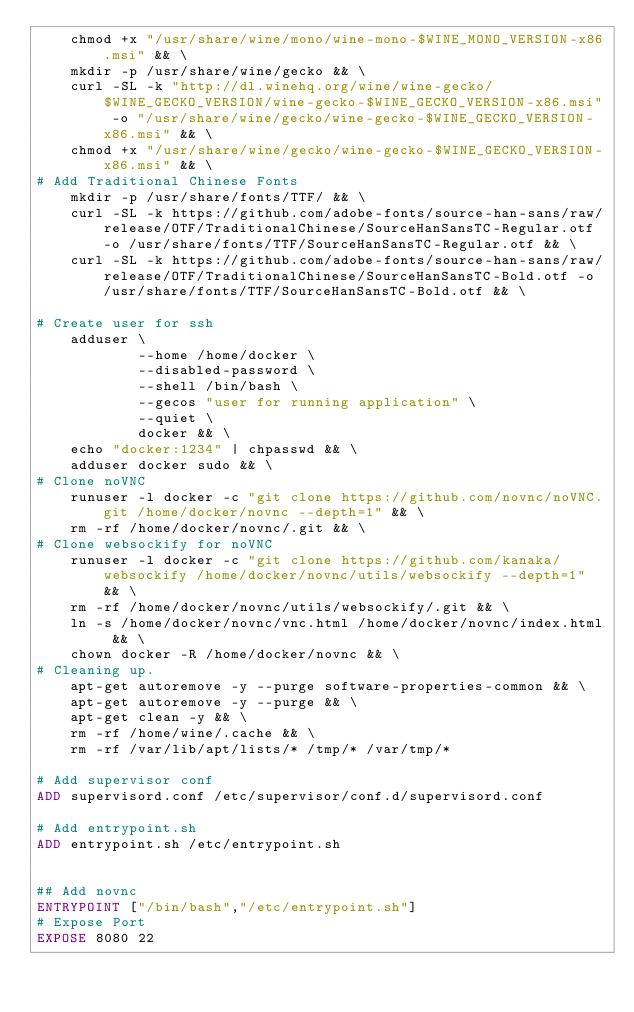<code> <loc_0><loc_0><loc_500><loc_500><_Dockerfile_>    chmod +x "/usr/share/wine/mono/wine-mono-$WINE_MONO_VERSION-x86.msi" && \
    mkdir -p /usr/share/wine/gecko && \
    curl -SL -k "http://dl.winehq.org/wine/wine-gecko/$WINE_GECKO_VERSION/wine-gecko-$WINE_GECKO_VERSION-x86.msi" -o "/usr/share/wine/gecko/wine-gecko-$WINE_GECKO_VERSION-x86.msi" && \
    chmod +x "/usr/share/wine/gecko/wine-gecko-$WINE_GECKO_VERSION-x86.msi" && \
# Add Traditional Chinese Fonts
    mkdir -p /usr/share/fonts/TTF/ && \
    curl -SL -k https://github.com/adobe-fonts/source-han-sans/raw/release/OTF/TraditionalChinese/SourceHanSansTC-Regular.otf -o /usr/share/fonts/TTF/SourceHanSansTC-Regular.otf && \
    curl -SL -k https://github.com/adobe-fonts/source-han-sans/raw/release/OTF/TraditionalChinese/SourceHanSansTC-Bold.otf -o /usr/share/fonts/TTF/SourceHanSansTC-Bold.otf && \

# Create user for ssh
    adduser \
            --home /home/docker \
            --disabled-password \
            --shell /bin/bash \
            --gecos "user for running application" \
            --quiet \
            docker && \
    echo "docker:1234" | chpasswd && \
    adduser docker sudo && \
# Clone noVNC
    runuser -l docker -c "git clone https://github.com/novnc/noVNC.git /home/docker/novnc --depth=1" && \
    rm -rf /home/docker/novnc/.git && \
# Clone websockify for noVNC
    runuser -l docker -c "git clone https://github.com/kanaka/websockify /home/docker/novnc/utils/websockify --depth=1" && \
    rm -rf /home/docker/novnc/utils/websockify/.git && \
    ln -s /home/docker/novnc/vnc.html /home/docker/novnc/index.html && \
    chown docker -R /home/docker/novnc && \
# Cleaning up.
    apt-get autoremove -y --purge software-properties-common && \
    apt-get autoremove -y --purge && \
    apt-get clean -y && \
    rm -rf /home/wine/.cache && \
    rm -rf /var/lib/apt/lists/* /tmp/* /var/tmp/*

# Add supervisor conf
ADD supervisord.conf /etc/supervisor/conf.d/supervisord.conf

# Add entrypoint.sh
ADD entrypoint.sh /etc/entrypoint.sh


## Add novnc
ENTRYPOINT ["/bin/bash","/etc/entrypoint.sh"]
# Expose Port
EXPOSE 8080 22
</code> 